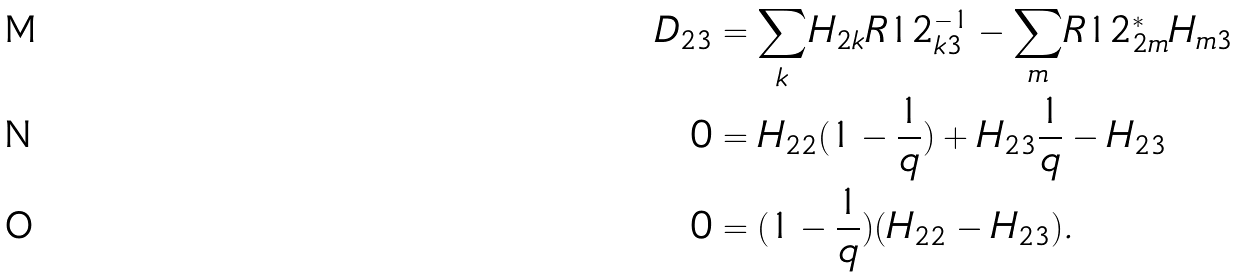<formula> <loc_0><loc_0><loc_500><loc_500>D _ { 2 3 } & = \underset { k } { \sum } H _ { 2 k } R 1 2 ^ { - 1 } _ { k 3 } - \underset { m } { \sum } R 1 2 ^ { * } _ { 2 m } H _ { m 3 } \\ 0 & = H _ { 2 2 } ( 1 - \frac { 1 } { q } ) + H _ { 2 3 } \frac { 1 } { q } - H _ { 2 3 } \\ 0 & = ( 1 - \frac { 1 } { q } ) ( H _ { 2 2 } - H _ { 2 3 } ) .</formula> 